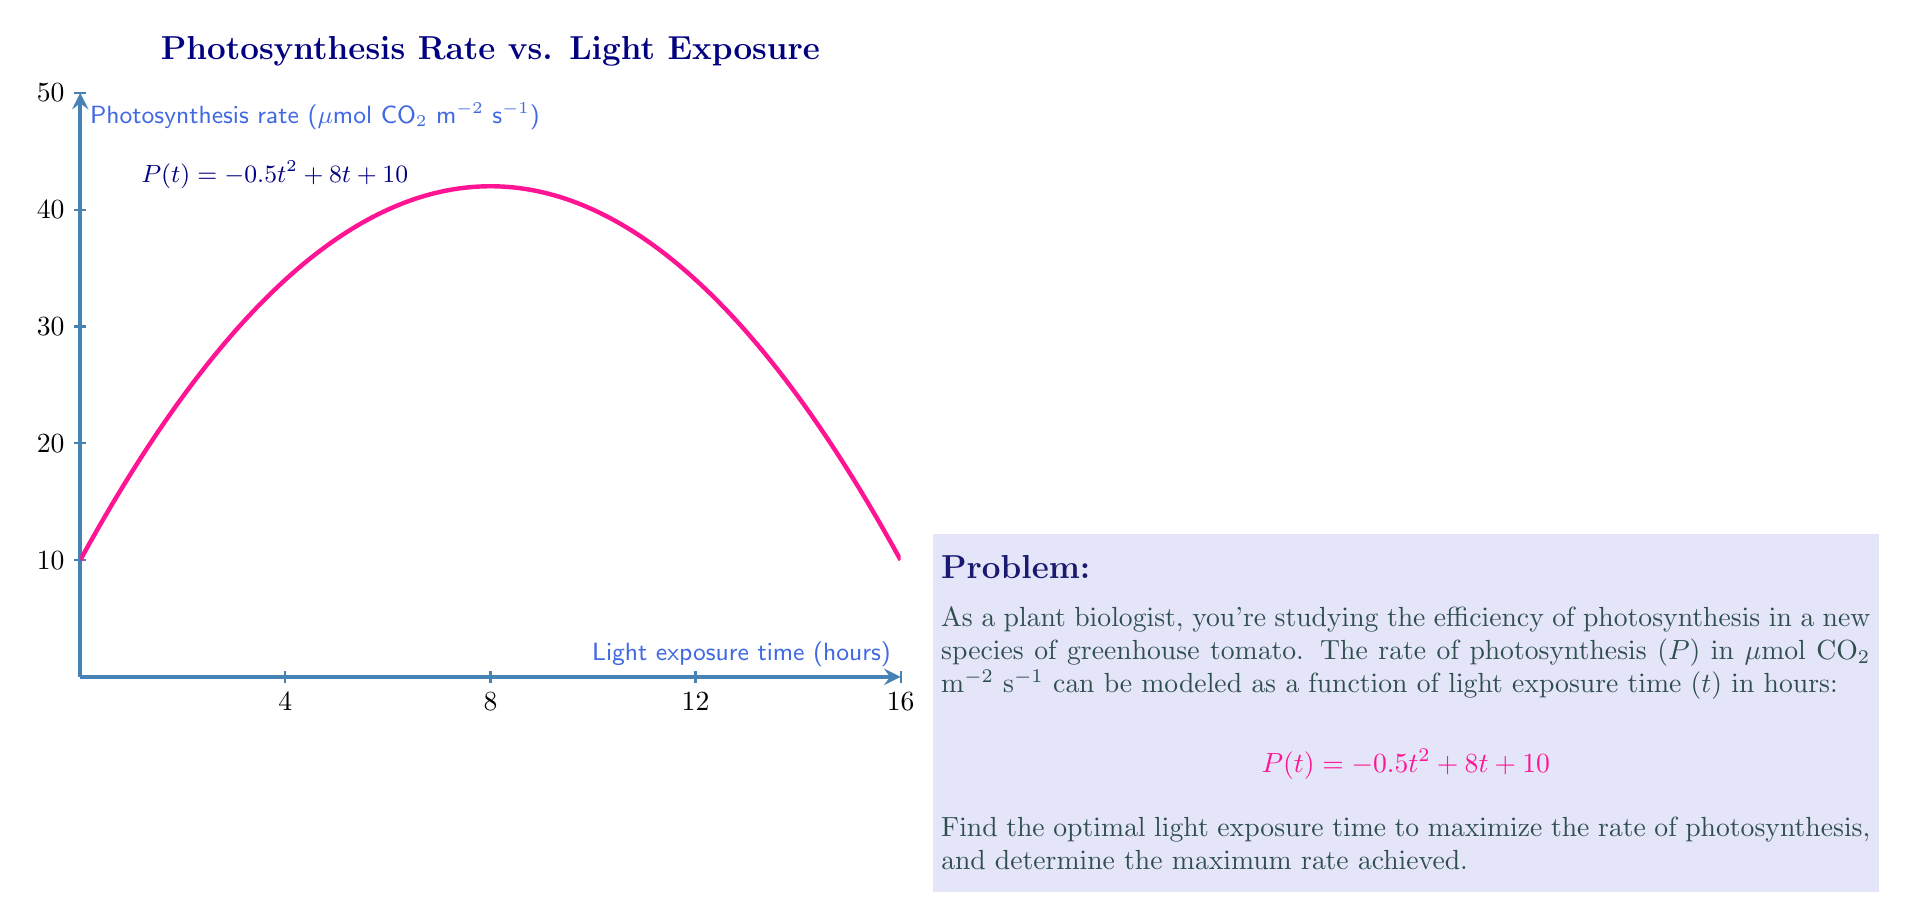Can you solve this math problem? To find the optimal light exposure time and maximum rate of photosynthesis, we need to follow these steps:

1) The rate of photosynthesis is given by the quadratic function:
   $$P(t) = -0.5t^2 + 8t + 10$$

2) To find the maximum of a quadratic function, we need to find the vertex. For a quadratic function in the form $f(x) = ax^2 + bx + c$, the x-coordinate of the vertex is given by $x = -\frac{b}{2a}$.

3) In our case, $a = -0.5$, $b = 8$, and $c = 10$. Let's calculate the optimal time $t$:

   $$t = -\frac{8}{2(-0.5)} = -\frac{8}{-1} = 8$$

4) This means the optimal light exposure time is 8 hours.

5) To find the maximum rate of photosynthesis, we need to calculate $P(8)$:

   $$P(8) = -0.5(8)^2 + 8(8) + 10$$
   $$= -0.5(64) + 64 + 10$$
   $$= -32 + 64 + 10$$
   $$= 42$$

Therefore, the maximum rate of photosynthesis is 42 μmol CO₂ m⁻² s⁻¹.
Answer: Optimal time: 8 hours; Maximum rate: 42 μmol CO₂ m⁻² s⁻¹ 